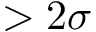Convert formula to latex. <formula><loc_0><loc_0><loc_500><loc_500>> 2 \sigma</formula> 